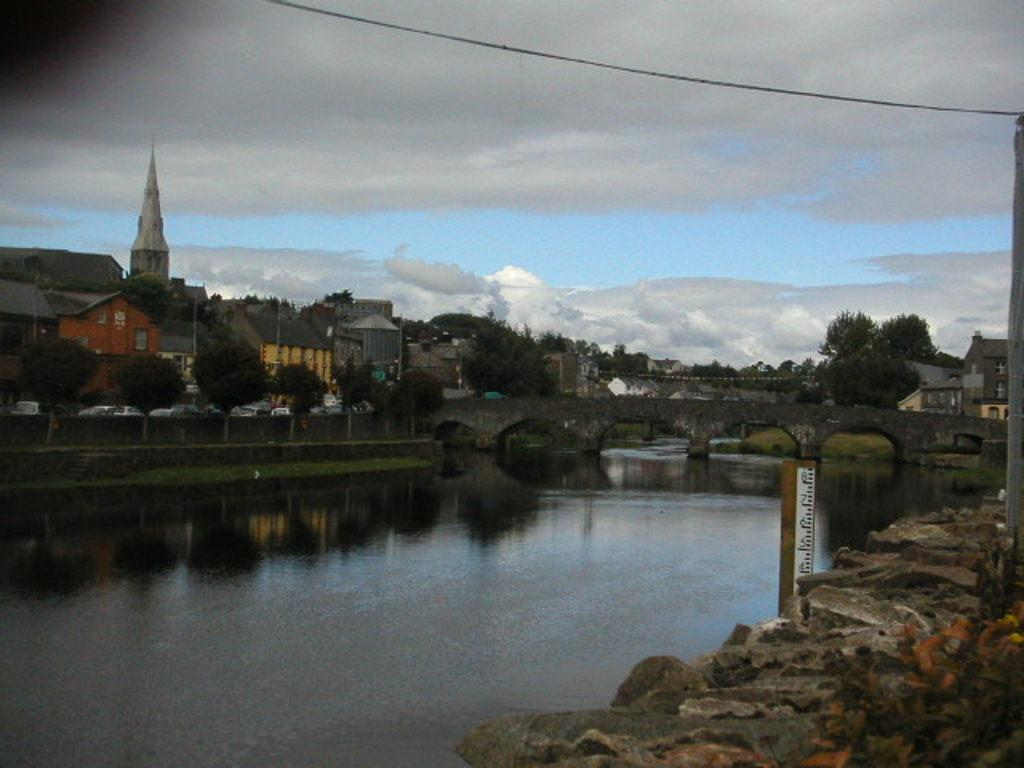What type of structures can be seen in the image? There are many buildings in the image. What is located in the middle of the image? There is a bridge in the middle of the image. What natural element is visible in the image? There is water visible in the image. What type of terrain is on the right side of the image? There is a hill or stony surface on the right side of the image. What is visible in the sky in the image? Clouds are visible in the sky. Can you see the hot spot on the bridge in the image? There is no mention of a hot spot in the image, and the image does not depict any hot spots. How many feet are visible on the hill in the image? There are no feet visible in the image, as it does not depict any people or animals. 